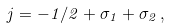Convert formula to latex. <formula><loc_0><loc_0><loc_500><loc_500>j = - 1 / 2 + \sigma _ { 1 } + \sigma _ { 2 } \, ,</formula> 